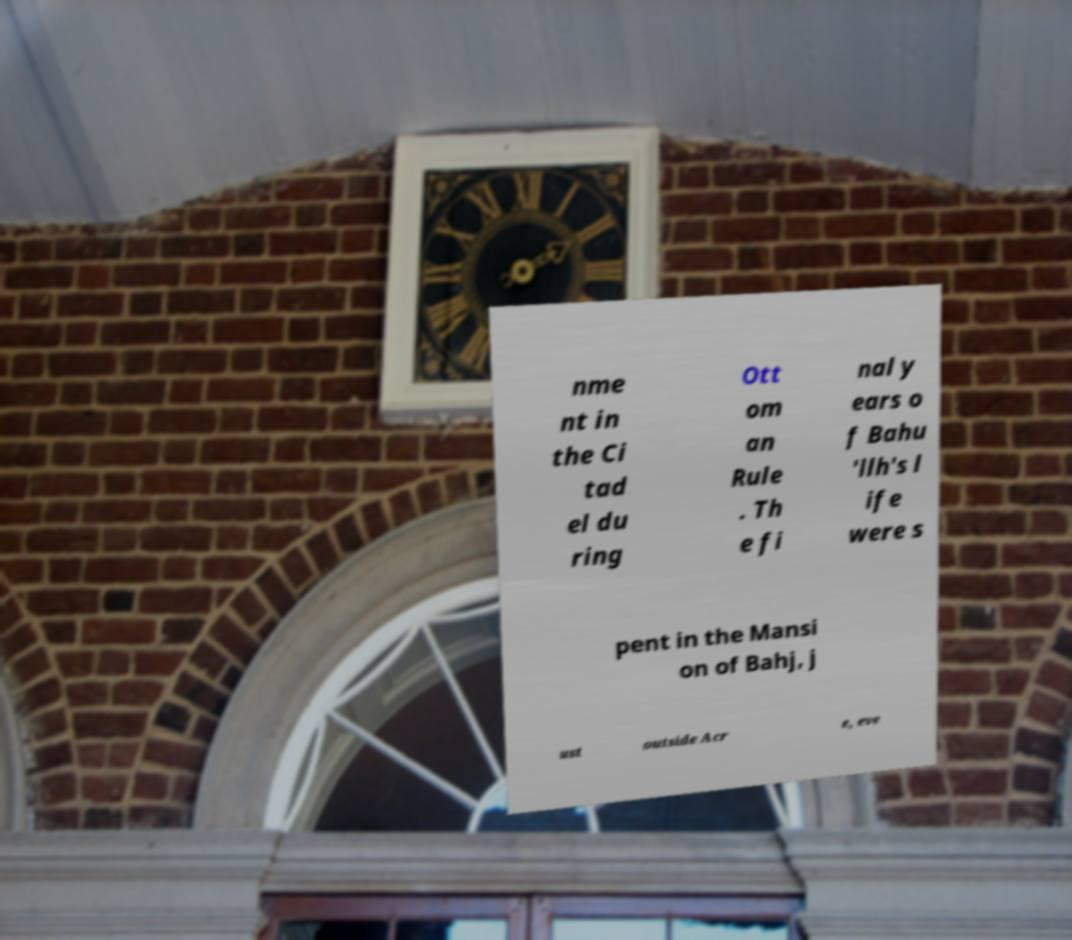Can you accurately transcribe the text from the provided image for me? nme nt in the Ci tad el du ring Ott om an Rule . Th e fi nal y ears o f Bahu 'llh's l ife were s pent in the Mansi on of Bahj, j ust outside Acr e, eve 